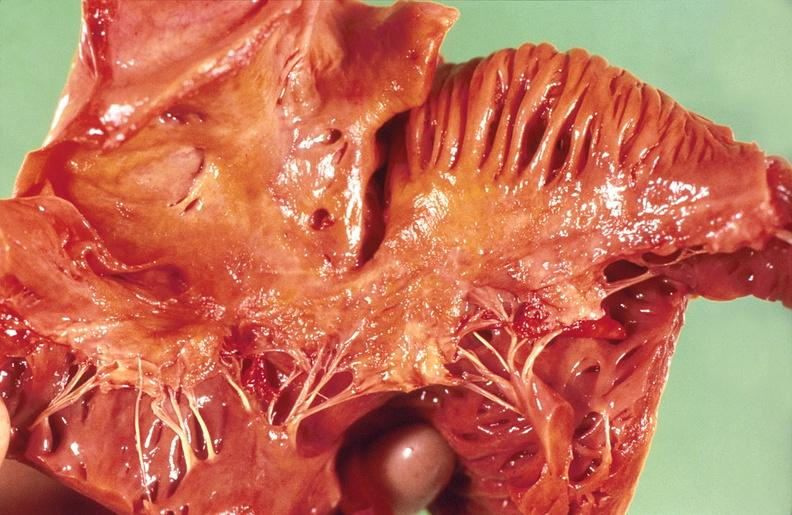what does this image show?
Answer the question using a single word or phrase. Amyloidosis 